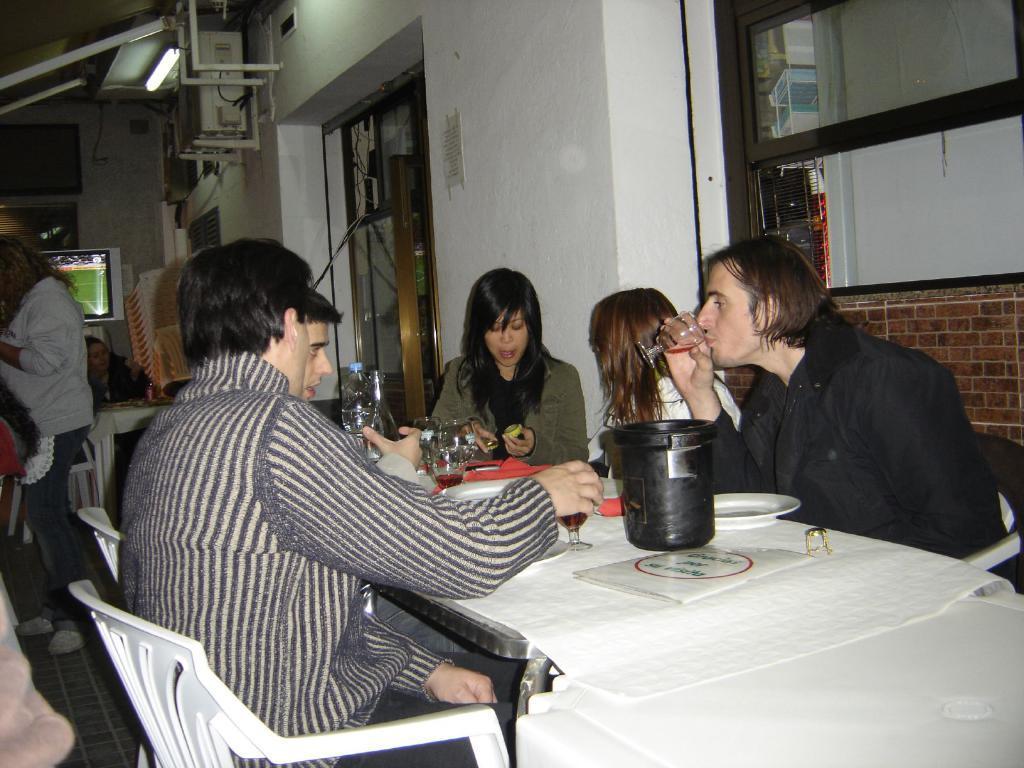Please provide a concise description of this image. In this image i can see few people sitting around a table, few of them are holding glasses in their hands, and in the background i can see a woman standing, a television screen and a light. 